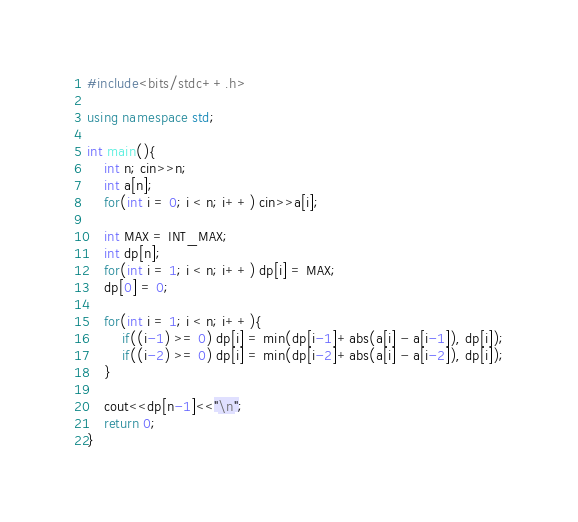Convert code to text. <code><loc_0><loc_0><loc_500><loc_500><_C++_>#include<bits/stdc++.h>

using namespace std;

int main(){
	int n; cin>>n;
	int a[n];
	for(int i = 0; i < n; i++) cin>>a[i];
	
	int MAX = INT_MAX;
	int dp[n];
	for(int i = 1; i < n; i++) dp[i] = MAX;
	dp[0] = 0;
	
	for(int i = 1; i < n; i++){
		if((i-1) >= 0) dp[i] = min(dp[i-1]+abs(a[i] - a[i-1]), dp[i]);
		if((i-2) >= 0) dp[i] = min(dp[i-2]+abs(a[i] - a[i-2]), dp[i]);
	}
	
	cout<<dp[n-1]<<"\n";
	return 0;
}</code> 